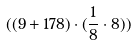Convert formula to latex. <formula><loc_0><loc_0><loc_500><loc_500>( ( 9 + 1 7 8 ) \cdot ( \frac { 1 } { 8 } \cdot 8 ) )</formula> 